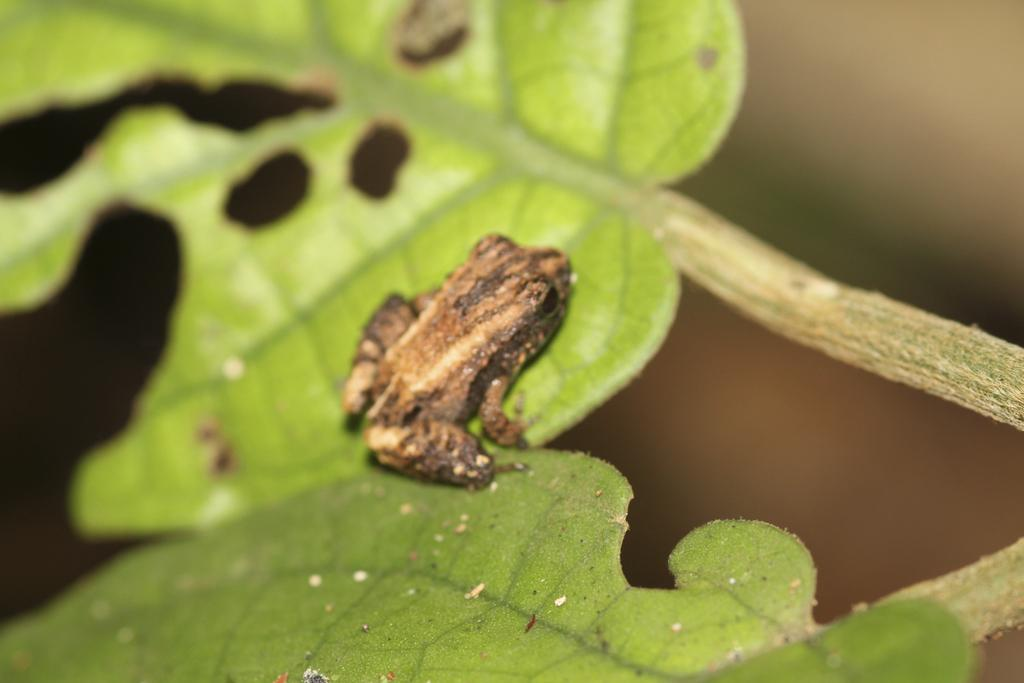What animal can be seen in the image? There is a frog in the image. Where is the frog located? The frog is on the leaves. What type of vegetation is visible in the image? There are leaves and stems visible in the image. How would you describe the background of the image? The background of the image has a blurred view. What is the governor doing in the image? There is no mention of a governor in the image, so we cannot answer this question. 